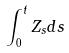<formula> <loc_0><loc_0><loc_500><loc_500>\int _ { 0 } ^ { t } Z _ { s } d s</formula> 